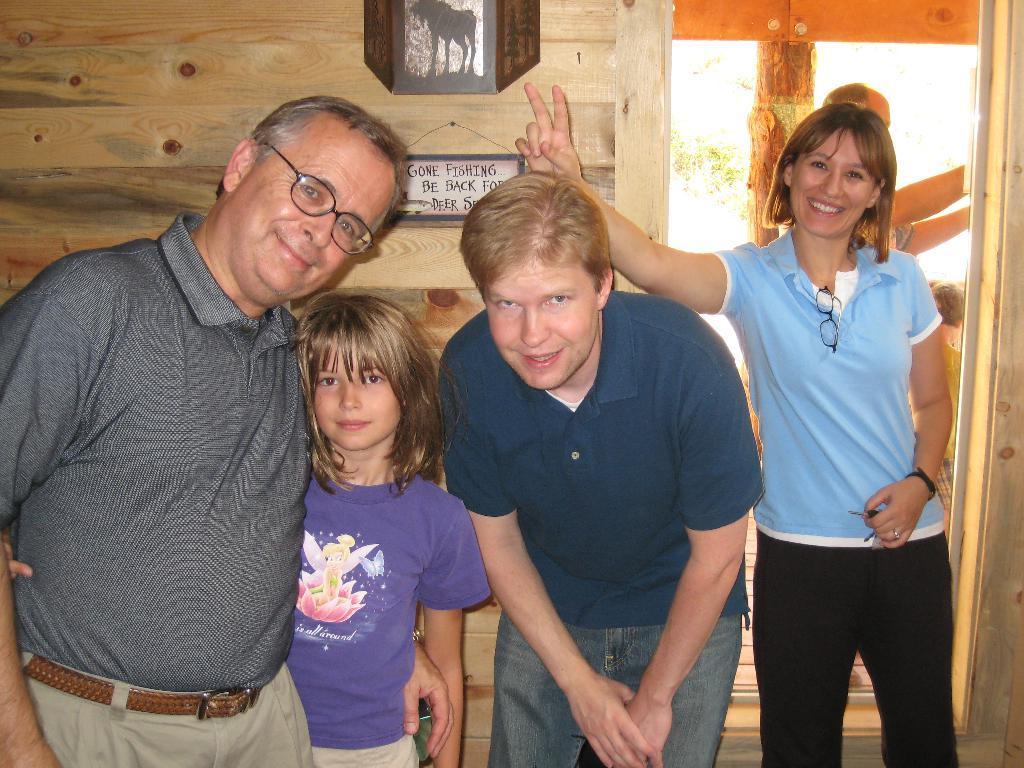Please provide a concise description of this image. In this picture we can see spectacles, four people standing and smiling and at the back of them we can see two people, name board on the wall and some objects. 